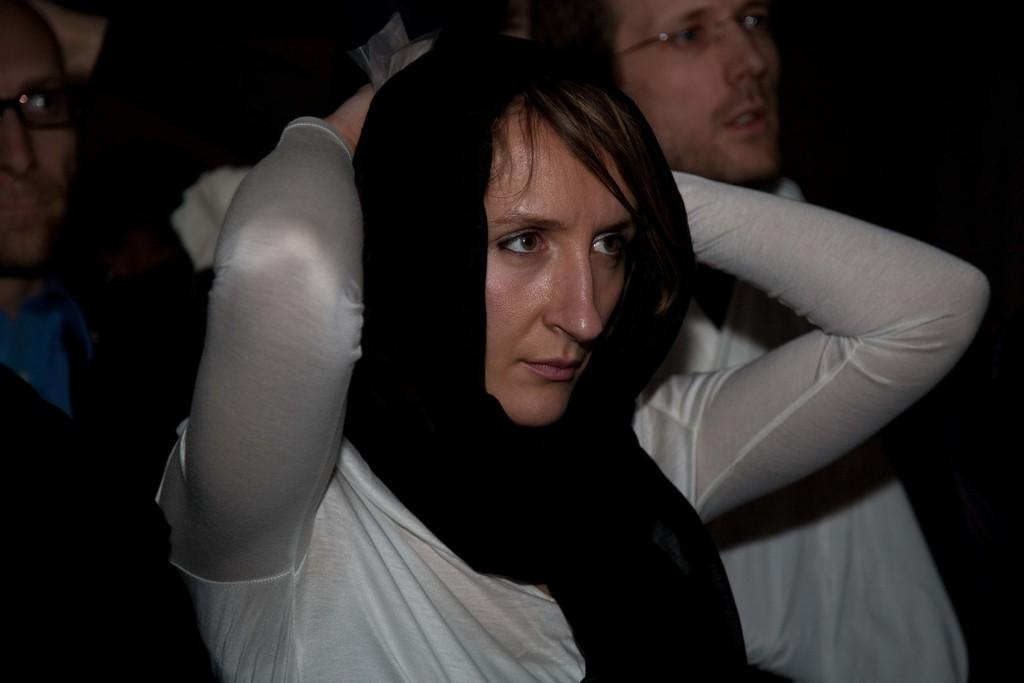What can be observed about the people in the image? There are people standing in the image. Can you describe any specific features of the men in the image? Some of the men in the image are wearing spectacles. What can be seen on the woman's head in the image? A woman in the image is wearing a black cloth on her head. What type of humor can be seen in the image? There is no humor present in the image; it depicts people standing and wearing specific clothing items. 